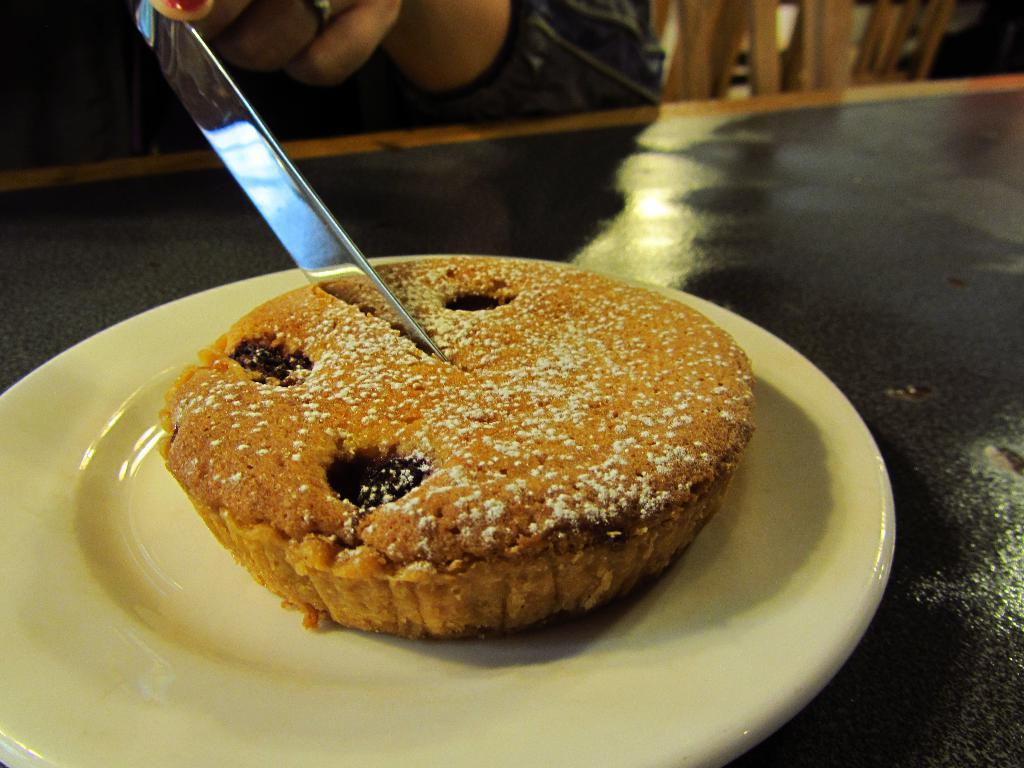What is on the plate in the image? There is food on a plate in the image, which resembles a cake. What is being used to cut the cake? A knife is cutting the cake in the image. Where is the plate with the cake located? The plate is placed on a table. What type of ink is being used to write on the cake in the image? There is no ink or writing on the cake in the image; it is being cut with a knife. Is there a baseball game happening in the background of the image? There is no baseball game or any reference to sports in the image; it features a plate with a cake on a table. 